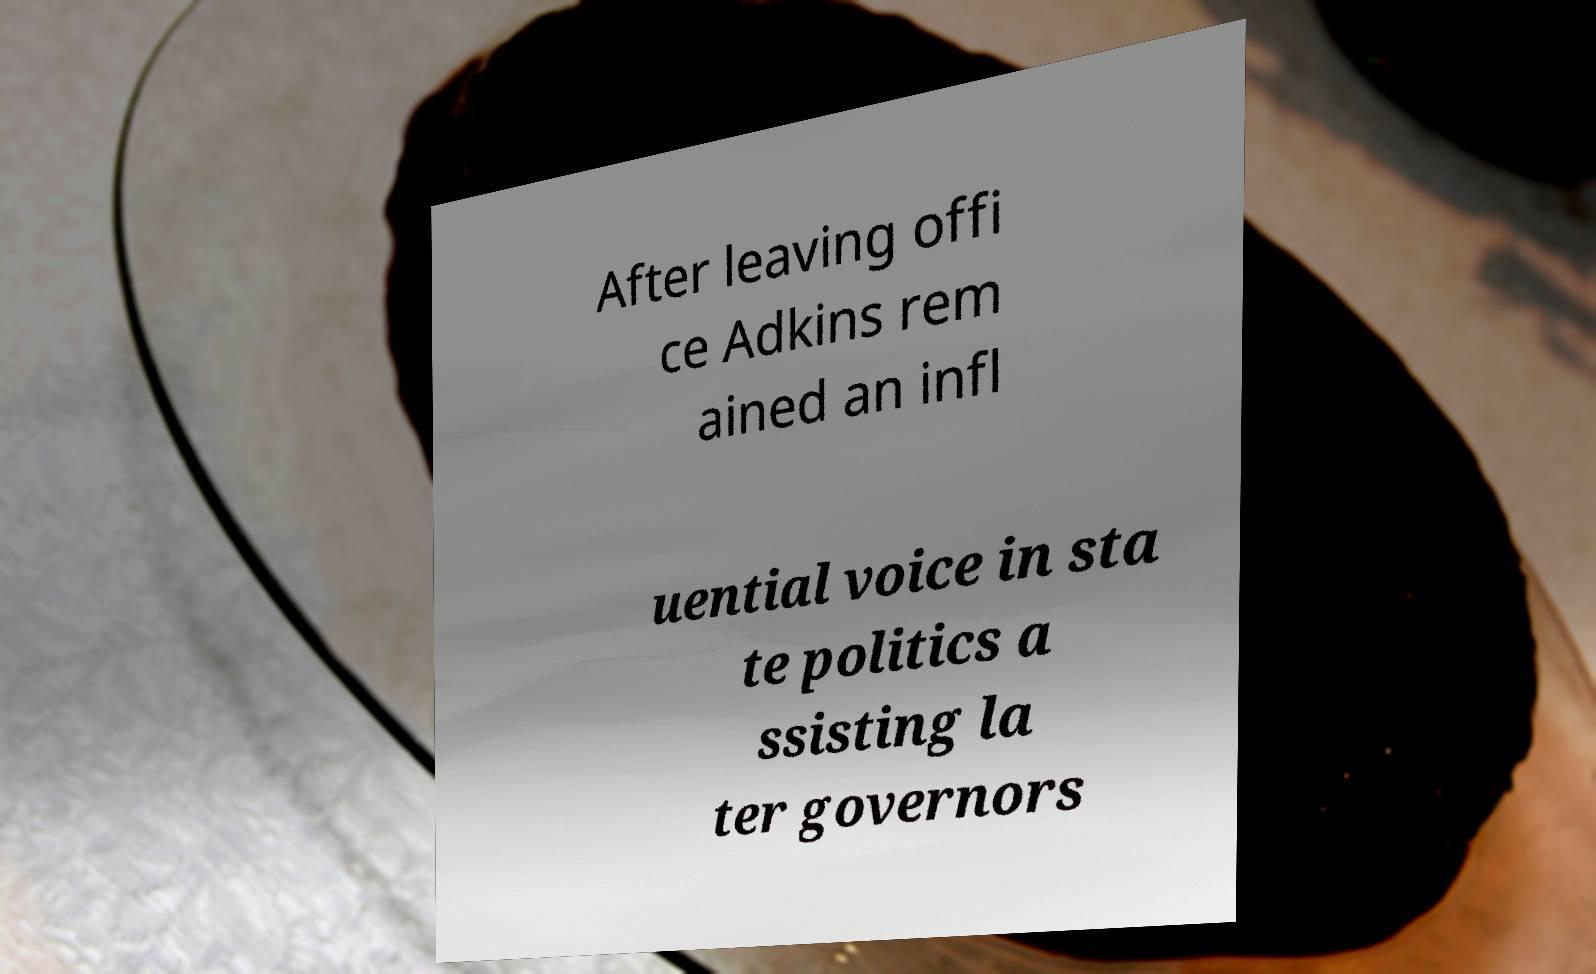Please read and relay the text visible in this image. What does it say? After leaving offi ce Adkins rem ained an infl uential voice in sta te politics a ssisting la ter governors 